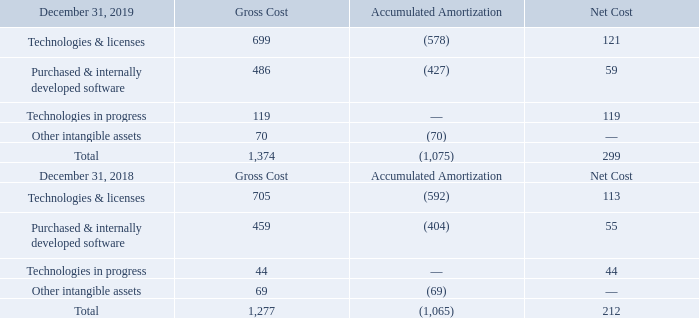As described in Note 7, the acquisition of Norstel resulted in the recognition of technology in process for $86 million in the line “Technologies in progress”.
The line “Technologies in progress” in the table above also includes internally developed software under construction and software not ready for use.
The amortization expense in 2019, 2018 and 2017 was $69 million, $64 million and $58 million, respectively.
What does Technologies in progress in the table include? Includes internally developed software under construction and software not ready for use. How much was the amortization expense in 2019? $69 million. How much was the amortization expense in 2018? $64 million. What is the average Gross Cost?
Answer scale should be: million. (1,374+1,277) / 2
Answer: 1325.5. What is the average Accumulated Amortization?
Answer scale should be: million. (1,075+1,065) / 2
Answer: 1070. What is the average Net Cost?
Answer scale should be: million. (299+212) / 2
Answer: 255.5. 